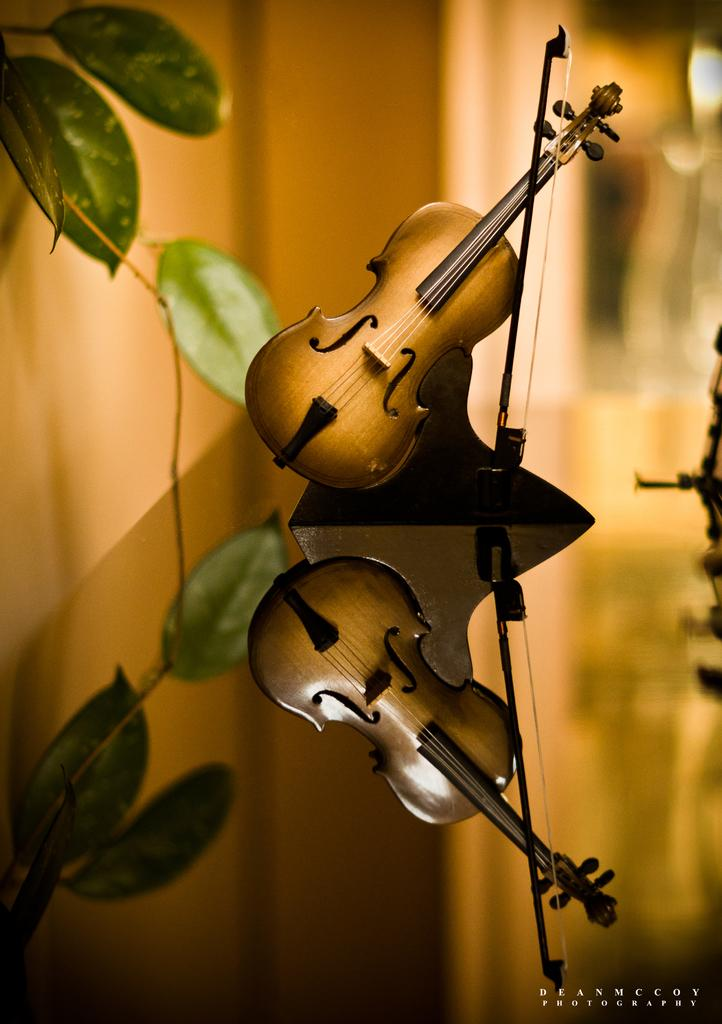What musical instruments can be seen in the image? There are two violins in the image. What else is present in the image besides the violins? There is an object and leaves visible in the image. How would you describe the background of the image? The background of the image is blurry. Is there any text present in the image? Yes, there is text in the bottom right corner of the image. What type of attention is the violin receiving in the market in the image? There is no reference to the market or attention in the image; it only shows two violins, an object, leaves, a blurry background, and text in the bottom right corner. 